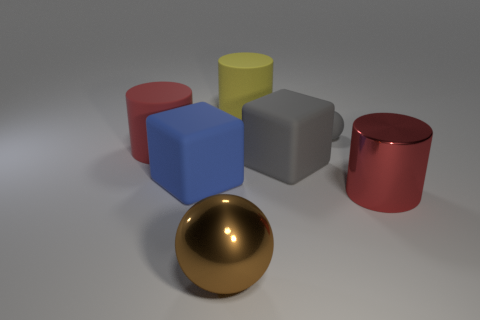Is the size of the metallic object in front of the red shiny thing the same as the red object behind the big blue rubber object?
Make the answer very short. Yes. Is the number of brown metal objects that are in front of the big gray block less than the number of shiny cylinders left of the large metal cylinder?
Offer a terse response. No. There is a big thing that is the same color as the small matte thing; what is it made of?
Your response must be concise. Rubber. There is a large metal thing that is on the left side of the big red shiny thing; what color is it?
Give a very brief answer. Brown. Do the big sphere and the rubber sphere have the same color?
Offer a very short reply. No. How many big rubber things are left of the sphere behind the red thing that is on the left side of the gray cube?
Provide a succinct answer. 4. The red rubber thing is what size?
Provide a short and direct response. Large. There is a yellow object that is the same size as the gray rubber cube; what material is it?
Keep it short and to the point. Rubber. There is a large gray thing; how many large shiny spheres are in front of it?
Your answer should be compact. 1. Is the material of the big cylinder in front of the red matte cylinder the same as the sphere that is behind the big brown metal ball?
Offer a very short reply. No. 